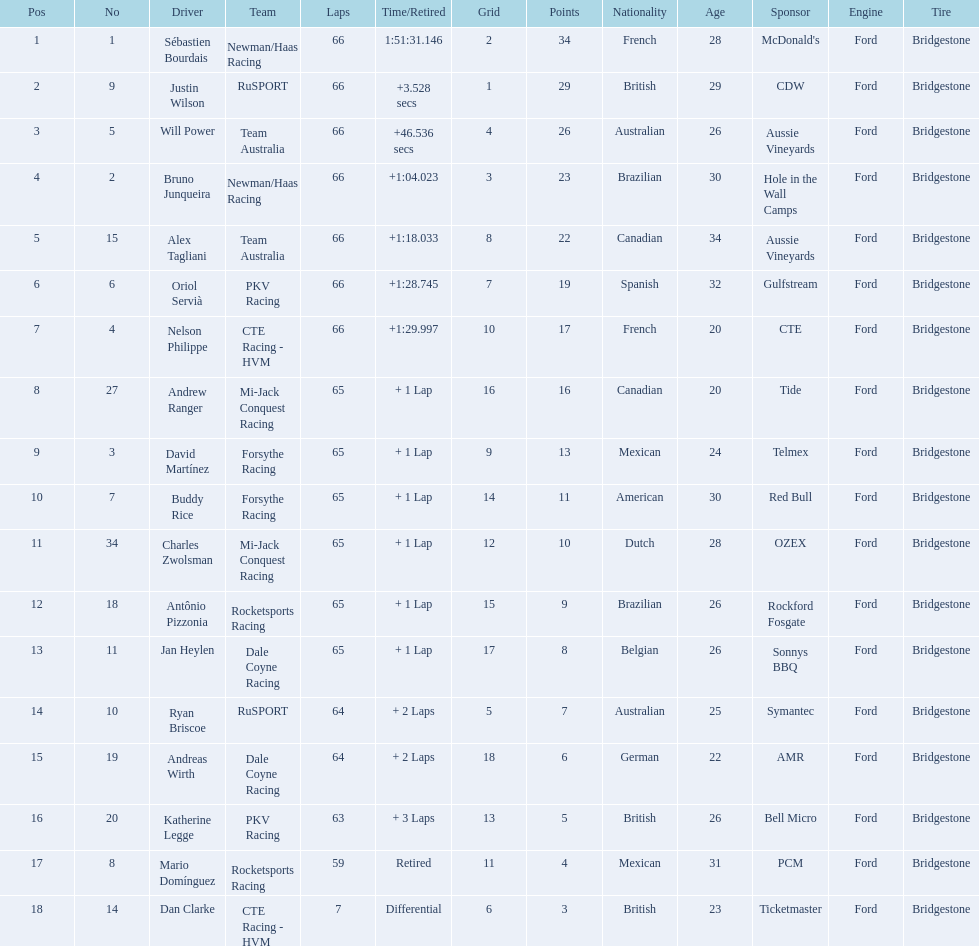Which driver has the same number as his/her position? Sébastien Bourdais. 